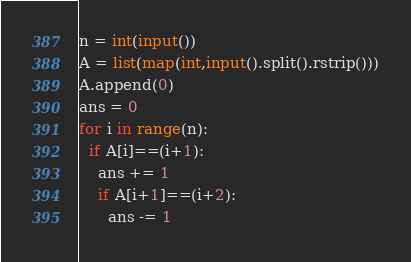<code> <loc_0><loc_0><loc_500><loc_500><_Python_>n = int(input())
A = list(map(int,input().split().rstrip()))
A.append(0)
ans = 0
for i in range(n):
  if A[i]==(i+1):
    ans += 1
    if A[i+1]==(i+2):
      ans -= 1</code> 